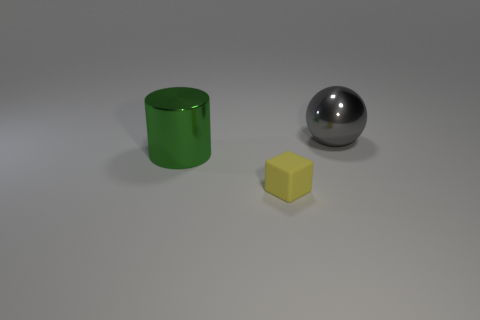Is the number of small rubber cubes that are behind the small yellow block greater than the number of green metallic objects?
Keep it short and to the point. No. There is a big thing that is right of the yellow thing; is it the same shape as the yellow rubber thing?
Your response must be concise. No. Is there anything else that is made of the same material as the big gray object?
Your response must be concise. Yes. What number of objects are tiny matte cubes or objects that are behind the small yellow cube?
Your answer should be very brief. 3. What size is the thing that is both on the left side of the gray sphere and behind the small yellow thing?
Provide a succinct answer. Large. Is the number of big gray balls behind the gray object greater than the number of large green things in front of the large green thing?
Your response must be concise. No. Does the gray object have the same shape as the large shiny object to the left of the large gray shiny object?
Your answer should be compact. No. What number of other objects are the same shape as the large gray object?
Offer a very short reply. 0. There is a thing that is both in front of the metallic ball and behind the rubber thing; what color is it?
Your answer should be compact. Green. The cube is what color?
Ensure brevity in your answer.  Yellow. 